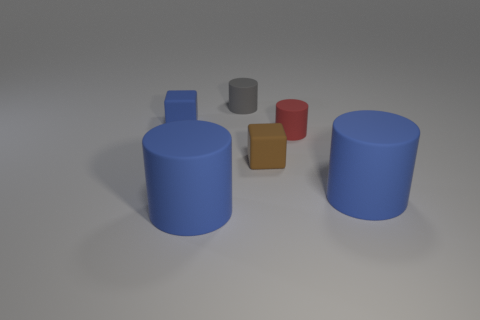Add 4 tiny red cylinders. How many objects exist? 10 Subtract all tiny red cylinders. How many cylinders are left? 3 Subtract 1 cubes. How many cubes are left? 1 Subtract all green spheres. How many blue cylinders are left? 2 Subtract all blue cylinders. How many cylinders are left? 2 Add 6 blue cylinders. How many blue cylinders are left? 8 Add 5 gray things. How many gray things exist? 6 Subtract 0 red balls. How many objects are left? 6 Subtract all cylinders. How many objects are left? 2 Subtract all gray cylinders. Subtract all brown spheres. How many cylinders are left? 3 